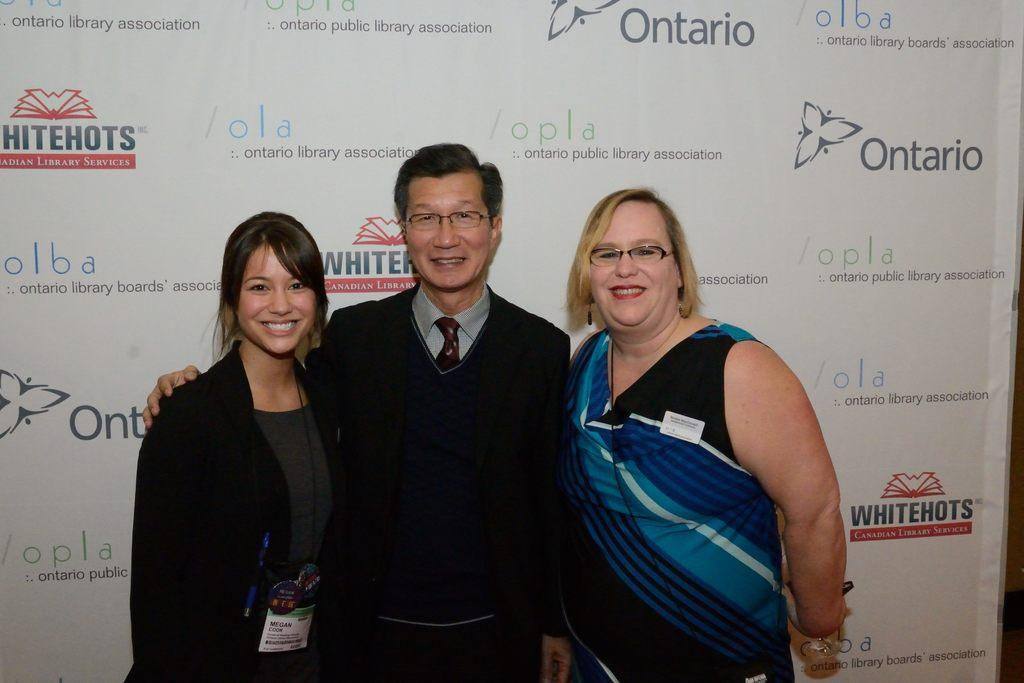Provide a one-sentence caption for the provided image. Two women and a man pose in front of the wall with signs that says "Whitehots Canadian Library services". 